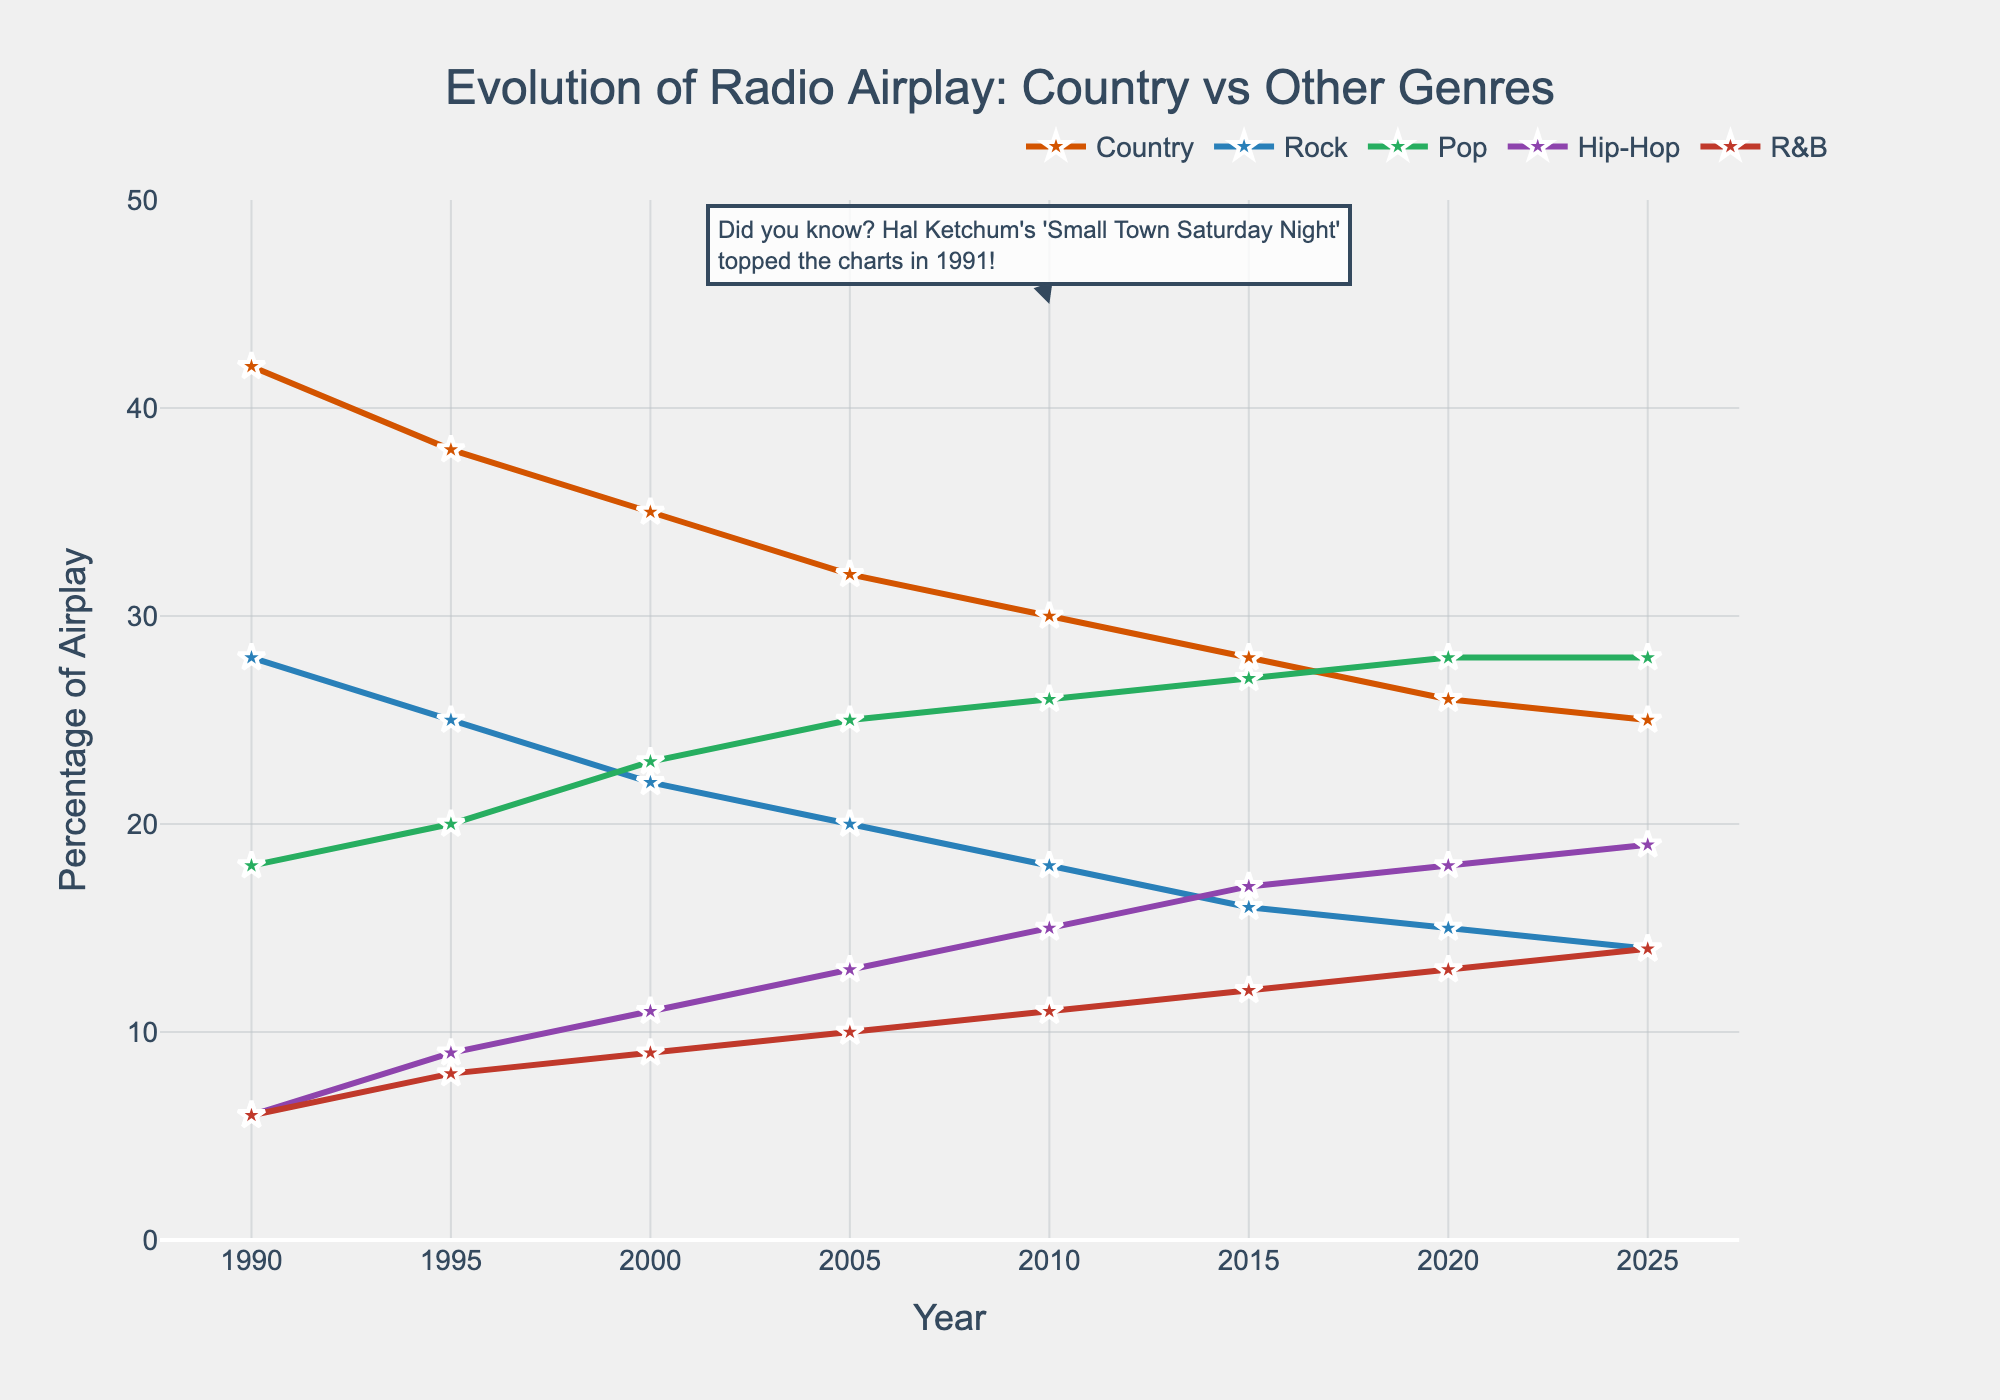Which genre experienced the greatest increase in airplay from 1990 to 2025? To find the genre with the greatest increase, compare the difference between the 2025 and 1990 values for each genre. The differences are: Country - 17%, Rock - 14%, Pop - 10%, Hip-Hop - 13%, R&B - 8%. Rock saw the biggest increase at 14%.
Answer: Rock What percentage of radio airplay did country music hold in 2000 compared to 2020? In 2000, country music held 35% of the radio airplay, while in 2020, it held 26%. This shows a decrease of 9 percentage points over the 20 years.
Answer: 35% and 26% Which genre surpassed country music in radio airplay percentage for the first time and when did it happen? Rock surpassed country music in 2015. Looking at the chart, in 2015, Rock had 16% whereas Country had 28%, but Rock had surpassed Country by 2020 with 18% vs 26%.
Answer: Rock in 2015 Compare the percentage of airplay of Hip-Hop and R&B in 2025. Which one is higher and by how much? In 2025, Hip-Hop has 19% airplay and R&B has 14%. The difference is 19% - 14% = 5%.
Answer: Hip-Hop by 5% How did the airplay of country music change from 1990 to 2005? In 1990, country music had 42% airplay. By 2005, it had decreased to 32%. The change is 42% - 32% = 10%.
Answer: Decreased by 10% What is the trend observed in the airplay of Pop music from 1990 to 2025? Pop music airplay increased steadily from 18% in 1990 to 28% in 2025. This indicates a consistent upward trend over the years.
Answer: Increasing From 2010 to 2025, which genre saw the smallest increase in airplay percentage? Analyze the change from 2010 to 2025. For Country, the change is 5% (from 30% to 25%). For Rock, it is 4% (from 18% to 14%). For Pop, it is 2% (from 26% to 28%). For Hip-Hop, it is 4% (from 15% to 19%). For R&B, it is 3% (from 11% to 14%). Pop had the smallest increase of 2%.
Answer: Pop What does the annotation about Hal Ketchum in the plot refer to? The annotation mentions that Hal Ketchum's 'Small Town Saturday Night' topped the charts in 1991. This provides a fun fact relevant to country music history but does not add numerical analysis to the plot.
Answer: Hal Ketchum's chart-topping song in 1991 